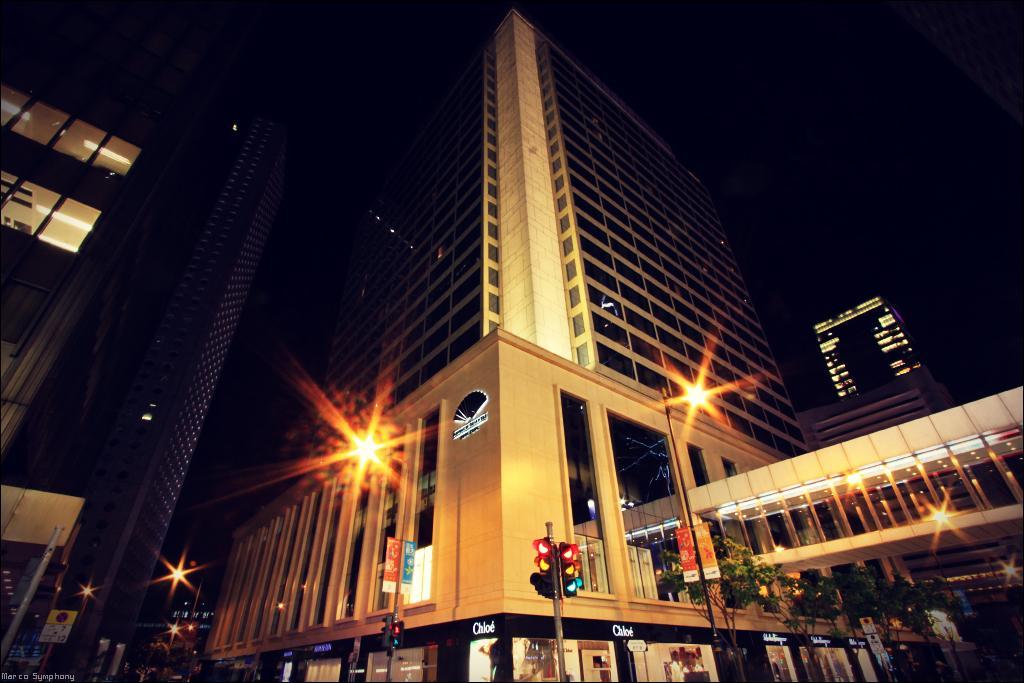In one or two sentences, can you explain what this image depicts? In this image there are buildings and we can see poles. There are lights. We can see traffic lights. On the right there are trees. In the background there is sky. 